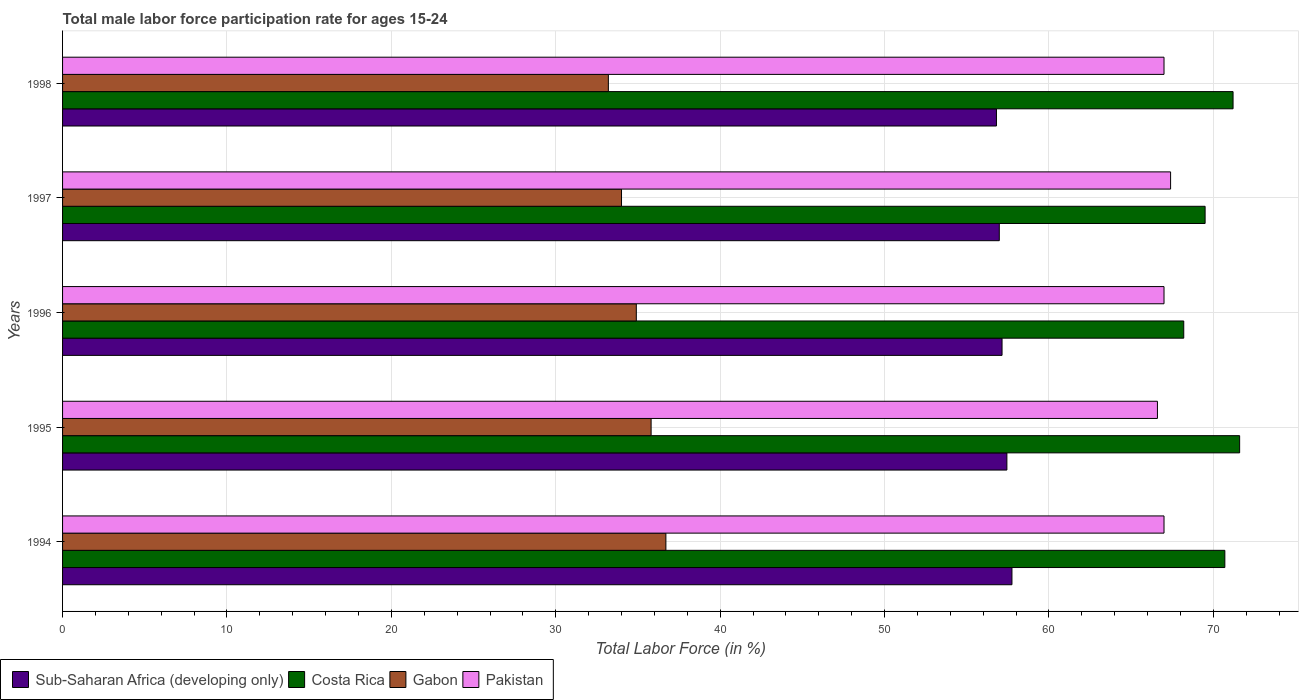How many different coloured bars are there?
Your response must be concise. 4. How many groups of bars are there?
Keep it short and to the point. 5. Are the number of bars on each tick of the Y-axis equal?
Keep it short and to the point. Yes. How many bars are there on the 4th tick from the top?
Your answer should be very brief. 4. How many bars are there on the 4th tick from the bottom?
Your response must be concise. 4. What is the male labor force participation rate in Costa Rica in 1997?
Make the answer very short. 69.5. Across all years, what is the maximum male labor force participation rate in Pakistan?
Give a very brief answer. 67.4. Across all years, what is the minimum male labor force participation rate in Gabon?
Offer a very short reply. 33.2. What is the total male labor force participation rate in Costa Rica in the graph?
Your response must be concise. 351.2. What is the difference between the male labor force participation rate in Gabon in 1994 and that in 1996?
Provide a short and direct response. 1.8. What is the difference between the male labor force participation rate in Sub-Saharan Africa (developing only) in 1994 and the male labor force participation rate in Costa Rica in 1995?
Provide a succinct answer. -13.85. What is the average male labor force participation rate in Sub-Saharan Africa (developing only) per year?
Provide a succinct answer. 57.23. In the year 1996, what is the difference between the male labor force participation rate in Costa Rica and male labor force participation rate in Gabon?
Offer a terse response. 33.3. In how many years, is the male labor force participation rate in Sub-Saharan Africa (developing only) greater than 18 %?
Your answer should be very brief. 5. What is the ratio of the male labor force participation rate in Pakistan in 1995 to that in 1997?
Make the answer very short. 0.99. What is the difference between the highest and the second highest male labor force participation rate in Sub-Saharan Africa (developing only)?
Offer a very short reply. 0.31. What is the difference between the highest and the lowest male labor force participation rate in Pakistan?
Your response must be concise. 0.8. What does the 4th bar from the top in 1998 represents?
Your answer should be compact. Sub-Saharan Africa (developing only). What does the 2nd bar from the bottom in 1996 represents?
Give a very brief answer. Costa Rica. Is it the case that in every year, the sum of the male labor force participation rate in Sub-Saharan Africa (developing only) and male labor force participation rate in Costa Rica is greater than the male labor force participation rate in Gabon?
Offer a terse response. Yes. How many bars are there?
Keep it short and to the point. 20. Are all the bars in the graph horizontal?
Provide a short and direct response. Yes. How many years are there in the graph?
Make the answer very short. 5. Where does the legend appear in the graph?
Your response must be concise. Bottom left. How are the legend labels stacked?
Offer a very short reply. Horizontal. What is the title of the graph?
Provide a short and direct response. Total male labor force participation rate for ages 15-24. Does "Antigua and Barbuda" appear as one of the legend labels in the graph?
Keep it short and to the point. No. What is the label or title of the Y-axis?
Your answer should be compact. Years. What is the Total Labor Force (in %) of Sub-Saharan Africa (developing only) in 1994?
Keep it short and to the point. 57.75. What is the Total Labor Force (in %) of Costa Rica in 1994?
Ensure brevity in your answer.  70.7. What is the Total Labor Force (in %) of Gabon in 1994?
Provide a short and direct response. 36.7. What is the Total Labor Force (in %) of Pakistan in 1994?
Ensure brevity in your answer.  67. What is the Total Labor Force (in %) of Sub-Saharan Africa (developing only) in 1995?
Provide a short and direct response. 57.44. What is the Total Labor Force (in %) of Costa Rica in 1995?
Offer a terse response. 71.6. What is the Total Labor Force (in %) of Gabon in 1995?
Offer a very short reply. 35.8. What is the Total Labor Force (in %) in Pakistan in 1995?
Provide a succinct answer. 66.6. What is the Total Labor Force (in %) in Sub-Saharan Africa (developing only) in 1996?
Offer a very short reply. 57.15. What is the Total Labor Force (in %) in Costa Rica in 1996?
Ensure brevity in your answer.  68.2. What is the Total Labor Force (in %) of Gabon in 1996?
Your response must be concise. 34.9. What is the Total Labor Force (in %) in Pakistan in 1996?
Provide a succinct answer. 67. What is the Total Labor Force (in %) in Sub-Saharan Africa (developing only) in 1997?
Give a very brief answer. 56.98. What is the Total Labor Force (in %) in Costa Rica in 1997?
Ensure brevity in your answer.  69.5. What is the Total Labor Force (in %) of Pakistan in 1997?
Your answer should be compact. 67.4. What is the Total Labor Force (in %) of Sub-Saharan Africa (developing only) in 1998?
Make the answer very short. 56.81. What is the Total Labor Force (in %) of Costa Rica in 1998?
Make the answer very short. 71.2. What is the Total Labor Force (in %) in Gabon in 1998?
Provide a succinct answer. 33.2. What is the Total Labor Force (in %) of Pakistan in 1998?
Your response must be concise. 67. Across all years, what is the maximum Total Labor Force (in %) in Sub-Saharan Africa (developing only)?
Give a very brief answer. 57.75. Across all years, what is the maximum Total Labor Force (in %) of Costa Rica?
Your answer should be very brief. 71.6. Across all years, what is the maximum Total Labor Force (in %) of Gabon?
Your answer should be very brief. 36.7. Across all years, what is the maximum Total Labor Force (in %) of Pakistan?
Give a very brief answer. 67.4. Across all years, what is the minimum Total Labor Force (in %) of Sub-Saharan Africa (developing only)?
Offer a terse response. 56.81. Across all years, what is the minimum Total Labor Force (in %) of Costa Rica?
Offer a very short reply. 68.2. Across all years, what is the minimum Total Labor Force (in %) in Gabon?
Make the answer very short. 33.2. Across all years, what is the minimum Total Labor Force (in %) in Pakistan?
Provide a succinct answer. 66.6. What is the total Total Labor Force (in %) in Sub-Saharan Africa (developing only) in the graph?
Make the answer very short. 286.13. What is the total Total Labor Force (in %) in Costa Rica in the graph?
Provide a short and direct response. 351.2. What is the total Total Labor Force (in %) of Gabon in the graph?
Give a very brief answer. 174.6. What is the total Total Labor Force (in %) of Pakistan in the graph?
Keep it short and to the point. 335. What is the difference between the Total Labor Force (in %) in Sub-Saharan Africa (developing only) in 1994 and that in 1995?
Provide a succinct answer. 0.31. What is the difference between the Total Labor Force (in %) in Costa Rica in 1994 and that in 1995?
Offer a very short reply. -0.9. What is the difference between the Total Labor Force (in %) of Sub-Saharan Africa (developing only) in 1994 and that in 1996?
Provide a short and direct response. 0.6. What is the difference between the Total Labor Force (in %) of Costa Rica in 1994 and that in 1996?
Offer a very short reply. 2.5. What is the difference between the Total Labor Force (in %) of Gabon in 1994 and that in 1996?
Provide a short and direct response. 1.8. What is the difference between the Total Labor Force (in %) of Sub-Saharan Africa (developing only) in 1994 and that in 1997?
Offer a terse response. 0.77. What is the difference between the Total Labor Force (in %) in Costa Rica in 1994 and that in 1997?
Provide a short and direct response. 1.2. What is the difference between the Total Labor Force (in %) of Gabon in 1994 and that in 1997?
Offer a very short reply. 2.7. What is the difference between the Total Labor Force (in %) in Pakistan in 1994 and that in 1997?
Give a very brief answer. -0.4. What is the difference between the Total Labor Force (in %) of Sub-Saharan Africa (developing only) in 1994 and that in 1998?
Make the answer very short. 0.94. What is the difference between the Total Labor Force (in %) of Costa Rica in 1994 and that in 1998?
Your answer should be very brief. -0.5. What is the difference between the Total Labor Force (in %) in Gabon in 1994 and that in 1998?
Provide a short and direct response. 3.5. What is the difference between the Total Labor Force (in %) of Sub-Saharan Africa (developing only) in 1995 and that in 1996?
Your answer should be very brief. 0.29. What is the difference between the Total Labor Force (in %) of Costa Rica in 1995 and that in 1996?
Offer a very short reply. 3.4. What is the difference between the Total Labor Force (in %) in Sub-Saharan Africa (developing only) in 1995 and that in 1997?
Offer a very short reply. 0.46. What is the difference between the Total Labor Force (in %) of Sub-Saharan Africa (developing only) in 1995 and that in 1998?
Make the answer very short. 0.63. What is the difference between the Total Labor Force (in %) of Costa Rica in 1995 and that in 1998?
Offer a terse response. 0.4. What is the difference between the Total Labor Force (in %) in Gabon in 1995 and that in 1998?
Offer a very short reply. 2.6. What is the difference between the Total Labor Force (in %) in Sub-Saharan Africa (developing only) in 1996 and that in 1997?
Offer a very short reply. 0.17. What is the difference between the Total Labor Force (in %) in Costa Rica in 1996 and that in 1997?
Provide a succinct answer. -1.3. What is the difference between the Total Labor Force (in %) in Pakistan in 1996 and that in 1997?
Offer a very short reply. -0.4. What is the difference between the Total Labor Force (in %) in Sub-Saharan Africa (developing only) in 1996 and that in 1998?
Offer a terse response. 0.34. What is the difference between the Total Labor Force (in %) in Gabon in 1996 and that in 1998?
Make the answer very short. 1.7. What is the difference between the Total Labor Force (in %) in Sub-Saharan Africa (developing only) in 1997 and that in 1998?
Your answer should be compact. 0.17. What is the difference between the Total Labor Force (in %) of Costa Rica in 1997 and that in 1998?
Give a very brief answer. -1.7. What is the difference between the Total Labor Force (in %) of Pakistan in 1997 and that in 1998?
Make the answer very short. 0.4. What is the difference between the Total Labor Force (in %) in Sub-Saharan Africa (developing only) in 1994 and the Total Labor Force (in %) in Costa Rica in 1995?
Give a very brief answer. -13.85. What is the difference between the Total Labor Force (in %) of Sub-Saharan Africa (developing only) in 1994 and the Total Labor Force (in %) of Gabon in 1995?
Your answer should be compact. 21.95. What is the difference between the Total Labor Force (in %) in Sub-Saharan Africa (developing only) in 1994 and the Total Labor Force (in %) in Pakistan in 1995?
Your response must be concise. -8.85. What is the difference between the Total Labor Force (in %) of Costa Rica in 1994 and the Total Labor Force (in %) of Gabon in 1995?
Your answer should be compact. 34.9. What is the difference between the Total Labor Force (in %) of Costa Rica in 1994 and the Total Labor Force (in %) of Pakistan in 1995?
Provide a succinct answer. 4.1. What is the difference between the Total Labor Force (in %) of Gabon in 1994 and the Total Labor Force (in %) of Pakistan in 1995?
Keep it short and to the point. -29.9. What is the difference between the Total Labor Force (in %) in Sub-Saharan Africa (developing only) in 1994 and the Total Labor Force (in %) in Costa Rica in 1996?
Provide a short and direct response. -10.45. What is the difference between the Total Labor Force (in %) of Sub-Saharan Africa (developing only) in 1994 and the Total Labor Force (in %) of Gabon in 1996?
Keep it short and to the point. 22.85. What is the difference between the Total Labor Force (in %) of Sub-Saharan Africa (developing only) in 1994 and the Total Labor Force (in %) of Pakistan in 1996?
Offer a terse response. -9.25. What is the difference between the Total Labor Force (in %) in Costa Rica in 1994 and the Total Labor Force (in %) in Gabon in 1996?
Your response must be concise. 35.8. What is the difference between the Total Labor Force (in %) in Gabon in 1994 and the Total Labor Force (in %) in Pakistan in 1996?
Your answer should be compact. -30.3. What is the difference between the Total Labor Force (in %) of Sub-Saharan Africa (developing only) in 1994 and the Total Labor Force (in %) of Costa Rica in 1997?
Give a very brief answer. -11.75. What is the difference between the Total Labor Force (in %) in Sub-Saharan Africa (developing only) in 1994 and the Total Labor Force (in %) in Gabon in 1997?
Keep it short and to the point. 23.75. What is the difference between the Total Labor Force (in %) in Sub-Saharan Africa (developing only) in 1994 and the Total Labor Force (in %) in Pakistan in 1997?
Offer a terse response. -9.65. What is the difference between the Total Labor Force (in %) in Costa Rica in 1994 and the Total Labor Force (in %) in Gabon in 1997?
Give a very brief answer. 36.7. What is the difference between the Total Labor Force (in %) in Costa Rica in 1994 and the Total Labor Force (in %) in Pakistan in 1997?
Give a very brief answer. 3.3. What is the difference between the Total Labor Force (in %) in Gabon in 1994 and the Total Labor Force (in %) in Pakistan in 1997?
Keep it short and to the point. -30.7. What is the difference between the Total Labor Force (in %) of Sub-Saharan Africa (developing only) in 1994 and the Total Labor Force (in %) of Costa Rica in 1998?
Your answer should be compact. -13.45. What is the difference between the Total Labor Force (in %) in Sub-Saharan Africa (developing only) in 1994 and the Total Labor Force (in %) in Gabon in 1998?
Provide a succinct answer. 24.55. What is the difference between the Total Labor Force (in %) in Sub-Saharan Africa (developing only) in 1994 and the Total Labor Force (in %) in Pakistan in 1998?
Provide a short and direct response. -9.25. What is the difference between the Total Labor Force (in %) in Costa Rica in 1994 and the Total Labor Force (in %) in Gabon in 1998?
Keep it short and to the point. 37.5. What is the difference between the Total Labor Force (in %) of Gabon in 1994 and the Total Labor Force (in %) of Pakistan in 1998?
Provide a short and direct response. -30.3. What is the difference between the Total Labor Force (in %) in Sub-Saharan Africa (developing only) in 1995 and the Total Labor Force (in %) in Costa Rica in 1996?
Ensure brevity in your answer.  -10.76. What is the difference between the Total Labor Force (in %) in Sub-Saharan Africa (developing only) in 1995 and the Total Labor Force (in %) in Gabon in 1996?
Your response must be concise. 22.54. What is the difference between the Total Labor Force (in %) of Sub-Saharan Africa (developing only) in 1995 and the Total Labor Force (in %) of Pakistan in 1996?
Make the answer very short. -9.56. What is the difference between the Total Labor Force (in %) of Costa Rica in 1995 and the Total Labor Force (in %) of Gabon in 1996?
Give a very brief answer. 36.7. What is the difference between the Total Labor Force (in %) in Costa Rica in 1995 and the Total Labor Force (in %) in Pakistan in 1996?
Ensure brevity in your answer.  4.6. What is the difference between the Total Labor Force (in %) of Gabon in 1995 and the Total Labor Force (in %) of Pakistan in 1996?
Provide a succinct answer. -31.2. What is the difference between the Total Labor Force (in %) in Sub-Saharan Africa (developing only) in 1995 and the Total Labor Force (in %) in Costa Rica in 1997?
Ensure brevity in your answer.  -12.06. What is the difference between the Total Labor Force (in %) of Sub-Saharan Africa (developing only) in 1995 and the Total Labor Force (in %) of Gabon in 1997?
Your answer should be compact. 23.44. What is the difference between the Total Labor Force (in %) in Sub-Saharan Africa (developing only) in 1995 and the Total Labor Force (in %) in Pakistan in 1997?
Make the answer very short. -9.96. What is the difference between the Total Labor Force (in %) in Costa Rica in 1995 and the Total Labor Force (in %) in Gabon in 1997?
Provide a succinct answer. 37.6. What is the difference between the Total Labor Force (in %) of Gabon in 1995 and the Total Labor Force (in %) of Pakistan in 1997?
Your answer should be compact. -31.6. What is the difference between the Total Labor Force (in %) in Sub-Saharan Africa (developing only) in 1995 and the Total Labor Force (in %) in Costa Rica in 1998?
Provide a short and direct response. -13.76. What is the difference between the Total Labor Force (in %) of Sub-Saharan Africa (developing only) in 1995 and the Total Labor Force (in %) of Gabon in 1998?
Give a very brief answer. 24.24. What is the difference between the Total Labor Force (in %) in Sub-Saharan Africa (developing only) in 1995 and the Total Labor Force (in %) in Pakistan in 1998?
Your answer should be compact. -9.56. What is the difference between the Total Labor Force (in %) in Costa Rica in 1995 and the Total Labor Force (in %) in Gabon in 1998?
Your response must be concise. 38.4. What is the difference between the Total Labor Force (in %) of Gabon in 1995 and the Total Labor Force (in %) of Pakistan in 1998?
Provide a succinct answer. -31.2. What is the difference between the Total Labor Force (in %) of Sub-Saharan Africa (developing only) in 1996 and the Total Labor Force (in %) of Costa Rica in 1997?
Keep it short and to the point. -12.35. What is the difference between the Total Labor Force (in %) of Sub-Saharan Africa (developing only) in 1996 and the Total Labor Force (in %) of Gabon in 1997?
Ensure brevity in your answer.  23.15. What is the difference between the Total Labor Force (in %) of Sub-Saharan Africa (developing only) in 1996 and the Total Labor Force (in %) of Pakistan in 1997?
Provide a short and direct response. -10.25. What is the difference between the Total Labor Force (in %) of Costa Rica in 1996 and the Total Labor Force (in %) of Gabon in 1997?
Provide a succinct answer. 34.2. What is the difference between the Total Labor Force (in %) of Gabon in 1996 and the Total Labor Force (in %) of Pakistan in 1997?
Ensure brevity in your answer.  -32.5. What is the difference between the Total Labor Force (in %) of Sub-Saharan Africa (developing only) in 1996 and the Total Labor Force (in %) of Costa Rica in 1998?
Offer a terse response. -14.05. What is the difference between the Total Labor Force (in %) in Sub-Saharan Africa (developing only) in 1996 and the Total Labor Force (in %) in Gabon in 1998?
Keep it short and to the point. 23.95. What is the difference between the Total Labor Force (in %) of Sub-Saharan Africa (developing only) in 1996 and the Total Labor Force (in %) of Pakistan in 1998?
Your response must be concise. -9.85. What is the difference between the Total Labor Force (in %) in Costa Rica in 1996 and the Total Labor Force (in %) in Pakistan in 1998?
Offer a very short reply. 1.2. What is the difference between the Total Labor Force (in %) of Gabon in 1996 and the Total Labor Force (in %) of Pakistan in 1998?
Offer a very short reply. -32.1. What is the difference between the Total Labor Force (in %) of Sub-Saharan Africa (developing only) in 1997 and the Total Labor Force (in %) of Costa Rica in 1998?
Give a very brief answer. -14.22. What is the difference between the Total Labor Force (in %) in Sub-Saharan Africa (developing only) in 1997 and the Total Labor Force (in %) in Gabon in 1998?
Keep it short and to the point. 23.78. What is the difference between the Total Labor Force (in %) in Sub-Saharan Africa (developing only) in 1997 and the Total Labor Force (in %) in Pakistan in 1998?
Provide a short and direct response. -10.02. What is the difference between the Total Labor Force (in %) of Costa Rica in 1997 and the Total Labor Force (in %) of Gabon in 1998?
Give a very brief answer. 36.3. What is the difference between the Total Labor Force (in %) in Costa Rica in 1997 and the Total Labor Force (in %) in Pakistan in 1998?
Offer a very short reply. 2.5. What is the difference between the Total Labor Force (in %) in Gabon in 1997 and the Total Labor Force (in %) in Pakistan in 1998?
Give a very brief answer. -33. What is the average Total Labor Force (in %) of Sub-Saharan Africa (developing only) per year?
Keep it short and to the point. 57.23. What is the average Total Labor Force (in %) in Costa Rica per year?
Make the answer very short. 70.24. What is the average Total Labor Force (in %) in Gabon per year?
Provide a succinct answer. 34.92. What is the average Total Labor Force (in %) of Pakistan per year?
Ensure brevity in your answer.  67. In the year 1994, what is the difference between the Total Labor Force (in %) in Sub-Saharan Africa (developing only) and Total Labor Force (in %) in Costa Rica?
Your answer should be compact. -12.95. In the year 1994, what is the difference between the Total Labor Force (in %) of Sub-Saharan Africa (developing only) and Total Labor Force (in %) of Gabon?
Offer a terse response. 21.05. In the year 1994, what is the difference between the Total Labor Force (in %) in Sub-Saharan Africa (developing only) and Total Labor Force (in %) in Pakistan?
Keep it short and to the point. -9.25. In the year 1994, what is the difference between the Total Labor Force (in %) in Gabon and Total Labor Force (in %) in Pakistan?
Your response must be concise. -30.3. In the year 1995, what is the difference between the Total Labor Force (in %) in Sub-Saharan Africa (developing only) and Total Labor Force (in %) in Costa Rica?
Make the answer very short. -14.16. In the year 1995, what is the difference between the Total Labor Force (in %) of Sub-Saharan Africa (developing only) and Total Labor Force (in %) of Gabon?
Give a very brief answer. 21.64. In the year 1995, what is the difference between the Total Labor Force (in %) in Sub-Saharan Africa (developing only) and Total Labor Force (in %) in Pakistan?
Your answer should be compact. -9.16. In the year 1995, what is the difference between the Total Labor Force (in %) in Costa Rica and Total Labor Force (in %) in Gabon?
Offer a very short reply. 35.8. In the year 1995, what is the difference between the Total Labor Force (in %) of Costa Rica and Total Labor Force (in %) of Pakistan?
Give a very brief answer. 5. In the year 1995, what is the difference between the Total Labor Force (in %) in Gabon and Total Labor Force (in %) in Pakistan?
Your answer should be compact. -30.8. In the year 1996, what is the difference between the Total Labor Force (in %) in Sub-Saharan Africa (developing only) and Total Labor Force (in %) in Costa Rica?
Offer a terse response. -11.05. In the year 1996, what is the difference between the Total Labor Force (in %) in Sub-Saharan Africa (developing only) and Total Labor Force (in %) in Gabon?
Your answer should be compact. 22.25. In the year 1996, what is the difference between the Total Labor Force (in %) in Sub-Saharan Africa (developing only) and Total Labor Force (in %) in Pakistan?
Offer a very short reply. -9.85. In the year 1996, what is the difference between the Total Labor Force (in %) in Costa Rica and Total Labor Force (in %) in Gabon?
Your response must be concise. 33.3. In the year 1996, what is the difference between the Total Labor Force (in %) in Gabon and Total Labor Force (in %) in Pakistan?
Ensure brevity in your answer.  -32.1. In the year 1997, what is the difference between the Total Labor Force (in %) in Sub-Saharan Africa (developing only) and Total Labor Force (in %) in Costa Rica?
Offer a very short reply. -12.52. In the year 1997, what is the difference between the Total Labor Force (in %) in Sub-Saharan Africa (developing only) and Total Labor Force (in %) in Gabon?
Offer a terse response. 22.98. In the year 1997, what is the difference between the Total Labor Force (in %) in Sub-Saharan Africa (developing only) and Total Labor Force (in %) in Pakistan?
Give a very brief answer. -10.42. In the year 1997, what is the difference between the Total Labor Force (in %) in Costa Rica and Total Labor Force (in %) in Gabon?
Ensure brevity in your answer.  35.5. In the year 1997, what is the difference between the Total Labor Force (in %) in Gabon and Total Labor Force (in %) in Pakistan?
Provide a short and direct response. -33.4. In the year 1998, what is the difference between the Total Labor Force (in %) in Sub-Saharan Africa (developing only) and Total Labor Force (in %) in Costa Rica?
Give a very brief answer. -14.39. In the year 1998, what is the difference between the Total Labor Force (in %) of Sub-Saharan Africa (developing only) and Total Labor Force (in %) of Gabon?
Offer a terse response. 23.61. In the year 1998, what is the difference between the Total Labor Force (in %) in Sub-Saharan Africa (developing only) and Total Labor Force (in %) in Pakistan?
Provide a short and direct response. -10.19. In the year 1998, what is the difference between the Total Labor Force (in %) in Costa Rica and Total Labor Force (in %) in Gabon?
Provide a short and direct response. 38. In the year 1998, what is the difference between the Total Labor Force (in %) in Gabon and Total Labor Force (in %) in Pakistan?
Your answer should be compact. -33.8. What is the ratio of the Total Labor Force (in %) of Sub-Saharan Africa (developing only) in 1994 to that in 1995?
Keep it short and to the point. 1.01. What is the ratio of the Total Labor Force (in %) in Costa Rica in 1994 to that in 1995?
Make the answer very short. 0.99. What is the ratio of the Total Labor Force (in %) in Gabon in 1994 to that in 1995?
Give a very brief answer. 1.03. What is the ratio of the Total Labor Force (in %) in Sub-Saharan Africa (developing only) in 1994 to that in 1996?
Your answer should be very brief. 1.01. What is the ratio of the Total Labor Force (in %) of Costa Rica in 1994 to that in 1996?
Keep it short and to the point. 1.04. What is the ratio of the Total Labor Force (in %) in Gabon in 1994 to that in 1996?
Your answer should be compact. 1.05. What is the ratio of the Total Labor Force (in %) of Pakistan in 1994 to that in 1996?
Your response must be concise. 1. What is the ratio of the Total Labor Force (in %) of Sub-Saharan Africa (developing only) in 1994 to that in 1997?
Make the answer very short. 1.01. What is the ratio of the Total Labor Force (in %) of Costa Rica in 1994 to that in 1997?
Your response must be concise. 1.02. What is the ratio of the Total Labor Force (in %) in Gabon in 1994 to that in 1997?
Your answer should be very brief. 1.08. What is the ratio of the Total Labor Force (in %) of Sub-Saharan Africa (developing only) in 1994 to that in 1998?
Offer a terse response. 1.02. What is the ratio of the Total Labor Force (in %) of Gabon in 1994 to that in 1998?
Keep it short and to the point. 1.11. What is the ratio of the Total Labor Force (in %) in Pakistan in 1994 to that in 1998?
Give a very brief answer. 1. What is the ratio of the Total Labor Force (in %) in Costa Rica in 1995 to that in 1996?
Your answer should be compact. 1.05. What is the ratio of the Total Labor Force (in %) in Gabon in 1995 to that in 1996?
Provide a succinct answer. 1.03. What is the ratio of the Total Labor Force (in %) in Sub-Saharan Africa (developing only) in 1995 to that in 1997?
Offer a terse response. 1.01. What is the ratio of the Total Labor Force (in %) in Costa Rica in 1995 to that in 1997?
Ensure brevity in your answer.  1.03. What is the ratio of the Total Labor Force (in %) in Gabon in 1995 to that in 1997?
Give a very brief answer. 1.05. What is the ratio of the Total Labor Force (in %) in Sub-Saharan Africa (developing only) in 1995 to that in 1998?
Offer a terse response. 1.01. What is the ratio of the Total Labor Force (in %) of Costa Rica in 1995 to that in 1998?
Offer a terse response. 1.01. What is the ratio of the Total Labor Force (in %) in Gabon in 1995 to that in 1998?
Offer a very short reply. 1.08. What is the ratio of the Total Labor Force (in %) of Pakistan in 1995 to that in 1998?
Offer a terse response. 0.99. What is the ratio of the Total Labor Force (in %) in Costa Rica in 1996 to that in 1997?
Make the answer very short. 0.98. What is the ratio of the Total Labor Force (in %) of Gabon in 1996 to that in 1997?
Provide a succinct answer. 1.03. What is the ratio of the Total Labor Force (in %) of Costa Rica in 1996 to that in 1998?
Your response must be concise. 0.96. What is the ratio of the Total Labor Force (in %) of Gabon in 1996 to that in 1998?
Ensure brevity in your answer.  1.05. What is the ratio of the Total Labor Force (in %) of Sub-Saharan Africa (developing only) in 1997 to that in 1998?
Your answer should be very brief. 1. What is the ratio of the Total Labor Force (in %) of Costa Rica in 1997 to that in 1998?
Give a very brief answer. 0.98. What is the ratio of the Total Labor Force (in %) of Gabon in 1997 to that in 1998?
Offer a terse response. 1.02. What is the ratio of the Total Labor Force (in %) of Pakistan in 1997 to that in 1998?
Offer a terse response. 1.01. What is the difference between the highest and the second highest Total Labor Force (in %) in Sub-Saharan Africa (developing only)?
Your answer should be very brief. 0.31. What is the difference between the highest and the second highest Total Labor Force (in %) in Pakistan?
Your answer should be very brief. 0.4. What is the difference between the highest and the lowest Total Labor Force (in %) in Sub-Saharan Africa (developing only)?
Offer a very short reply. 0.94. What is the difference between the highest and the lowest Total Labor Force (in %) of Gabon?
Offer a terse response. 3.5. What is the difference between the highest and the lowest Total Labor Force (in %) of Pakistan?
Provide a short and direct response. 0.8. 